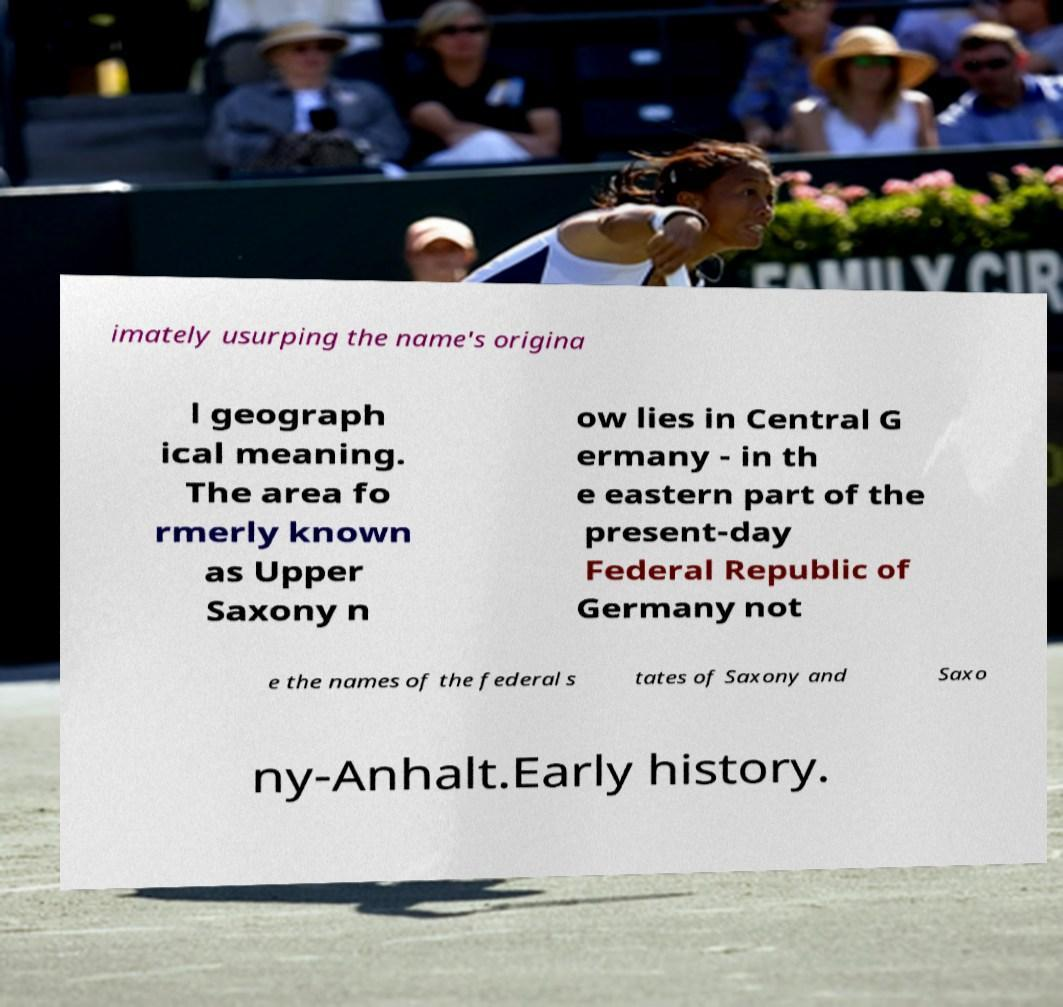What messages or text are displayed in this image? I need them in a readable, typed format. imately usurping the name's origina l geograph ical meaning. The area fo rmerly known as Upper Saxony n ow lies in Central G ermany - in th e eastern part of the present-day Federal Republic of Germany not e the names of the federal s tates of Saxony and Saxo ny-Anhalt.Early history. 